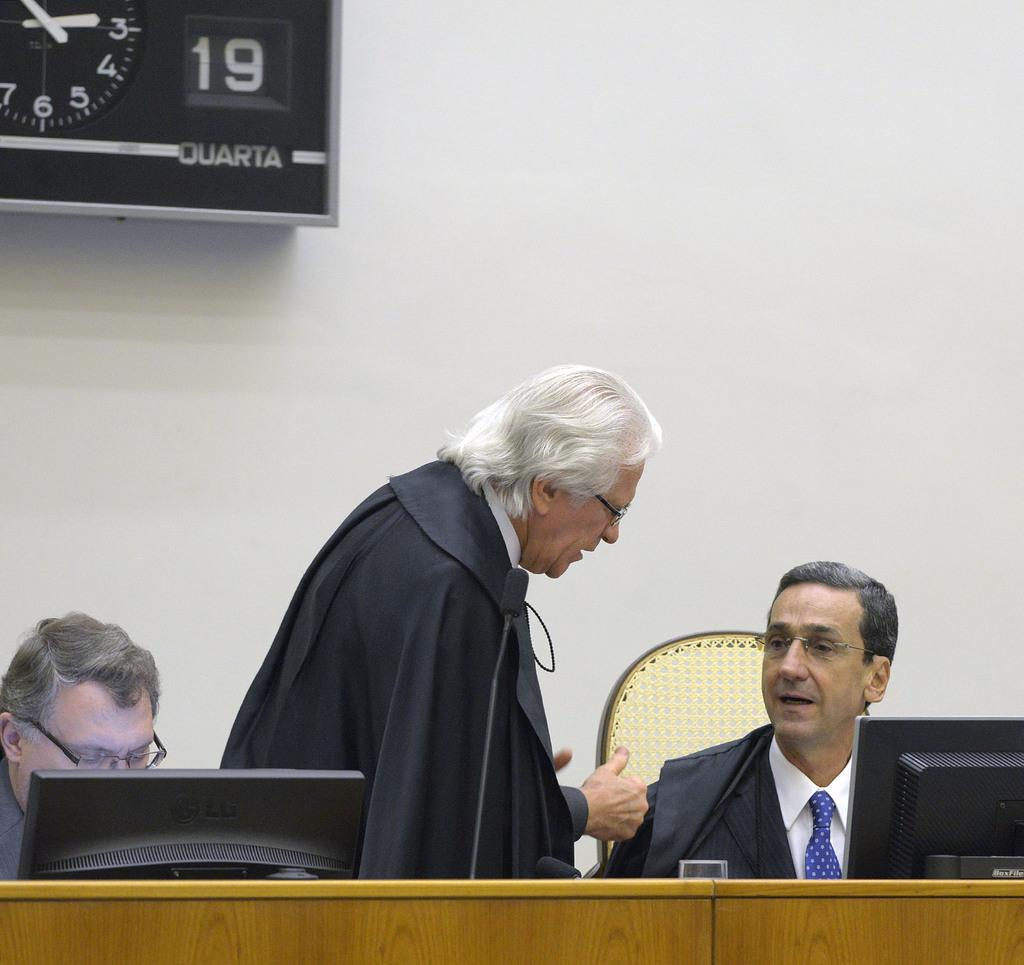What is the color of the wall in the image? The wall in the image is white. What object can be used to tell time in the image? There is a clock in the image. How many people are present in the image? There are three people in the image. What type of furniture is in the image? There are chairs and a table in the image. What is placed on the table in the image? There is a glass and screens on the table. Are there any flowers growing on the wall in the image? No, there are no flowers growing on the wall in the image. Can you describe the curve of the table in the image? There is no curve mentioned in the description of the table in the image; it is simply described as a table. 